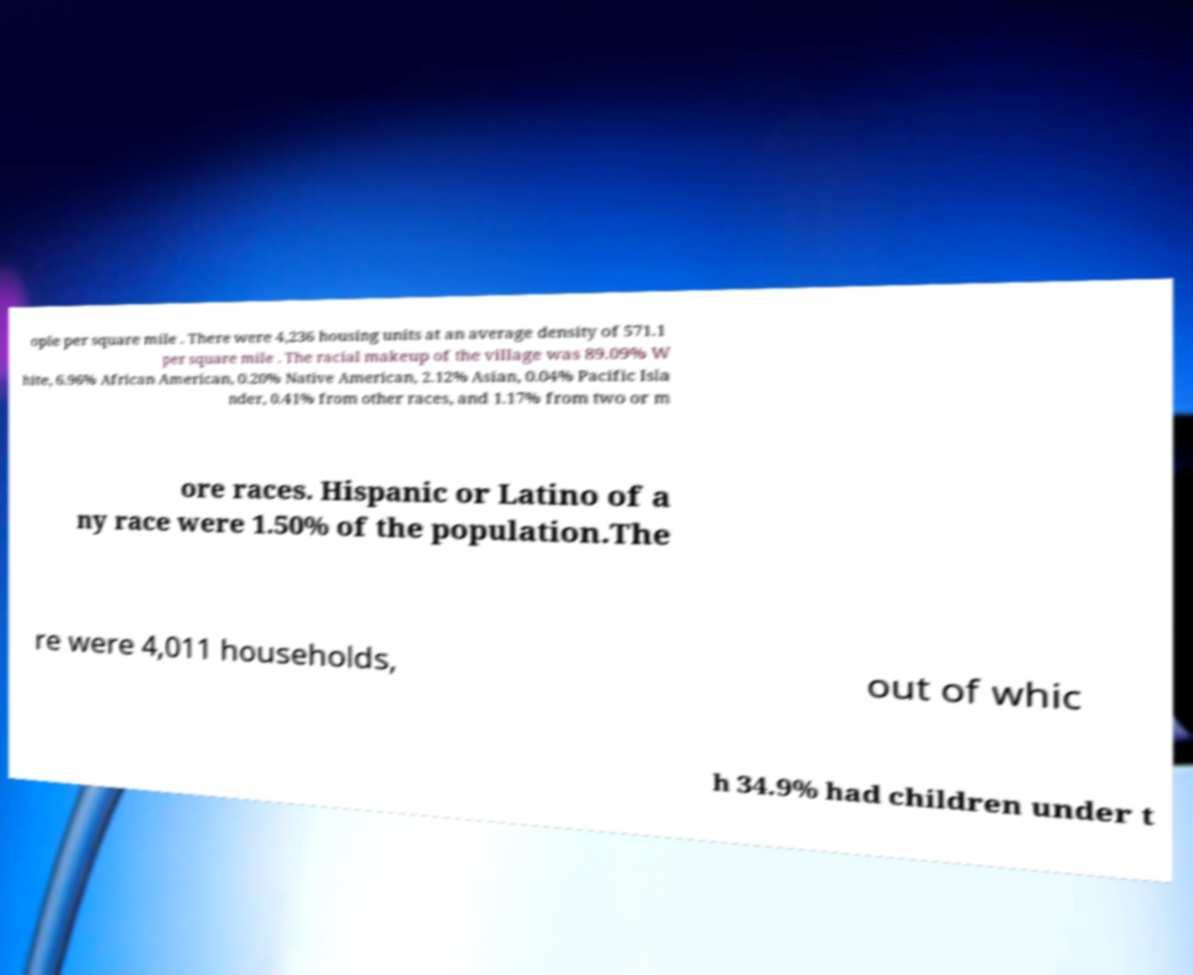Could you assist in decoding the text presented in this image and type it out clearly? ople per square mile . There were 4,236 housing units at an average density of 571.1 per square mile . The racial makeup of the village was 89.09% W hite, 6.96% African American, 0.20% Native American, 2.12% Asian, 0.04% Pacific Isla nder, 0.41% from other races, and 1.17% from two or m ore races. Hispanic or Latino of a ny race were 1.50% of the population.The re were 4,011 households, out of whic h 34.9% had children under t 